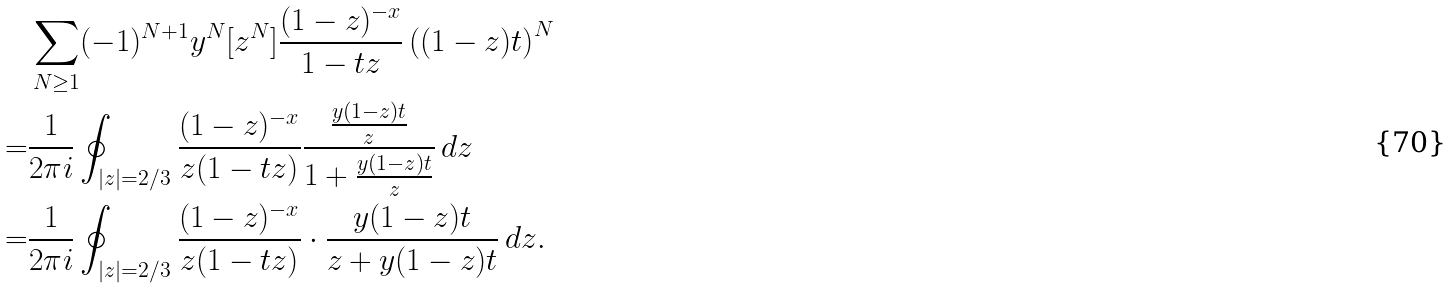Convert formula to latex. <formula><loc_0><loc_0><loc_500><loc_500>& \sum _ { N \geq 1 } ( - 1 ) ^ { N + 1 } y ^ { N } [ z ^ { N } ] \frac { ( 1 - z ) ^ { - x } } { 1 - t z } \left ( ( 1 - z ) t \right ) ^ { N } \\ = & \frac { 1 } { 2 \pi i } \oint _ { | z | = 2 / 3 } \frac { ( 1 - z ) ^ { - x } } { z ( 1 - t z ) } \frac { \frac { y ( 1 - z ) t } { z } } { 1 + \frac { y ( 1 - z ) t } { z } } \, d z \\ = & \frac { 1 } { 2 \pi i } \oint _ { | z | = 2 / 3 } \frac { ( 1 - z ) ^ { - x } } { z ( 1 - t z ) } \cdot \frac { y ( 1 - z ) t } { z + y ( 1 - z ) t } \, d z .</formula> 